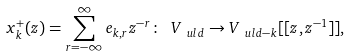<formula> <loc_0><loc_0><loc_500><loc_500>x _ { k } ^ { + } ( z ) = \sum _ { r = - \infty } ^ { \infty } e _ { k , r } z ^ { - r } \colon \ V _ { \ u l { d } } \to V _ { \ u l { d } - k } [ [ z , z ^ { - 1 } ] ] ,</formula> 